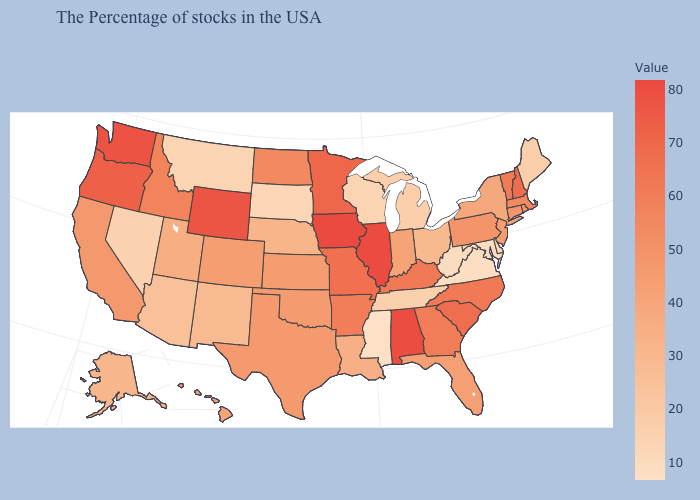Among the states that border Pennsylvania , does New Jersey have the highest value?
Quick response, please. Yes. Does Mississippi have the lowest value in the USA?
Quick response, please. Yes. 